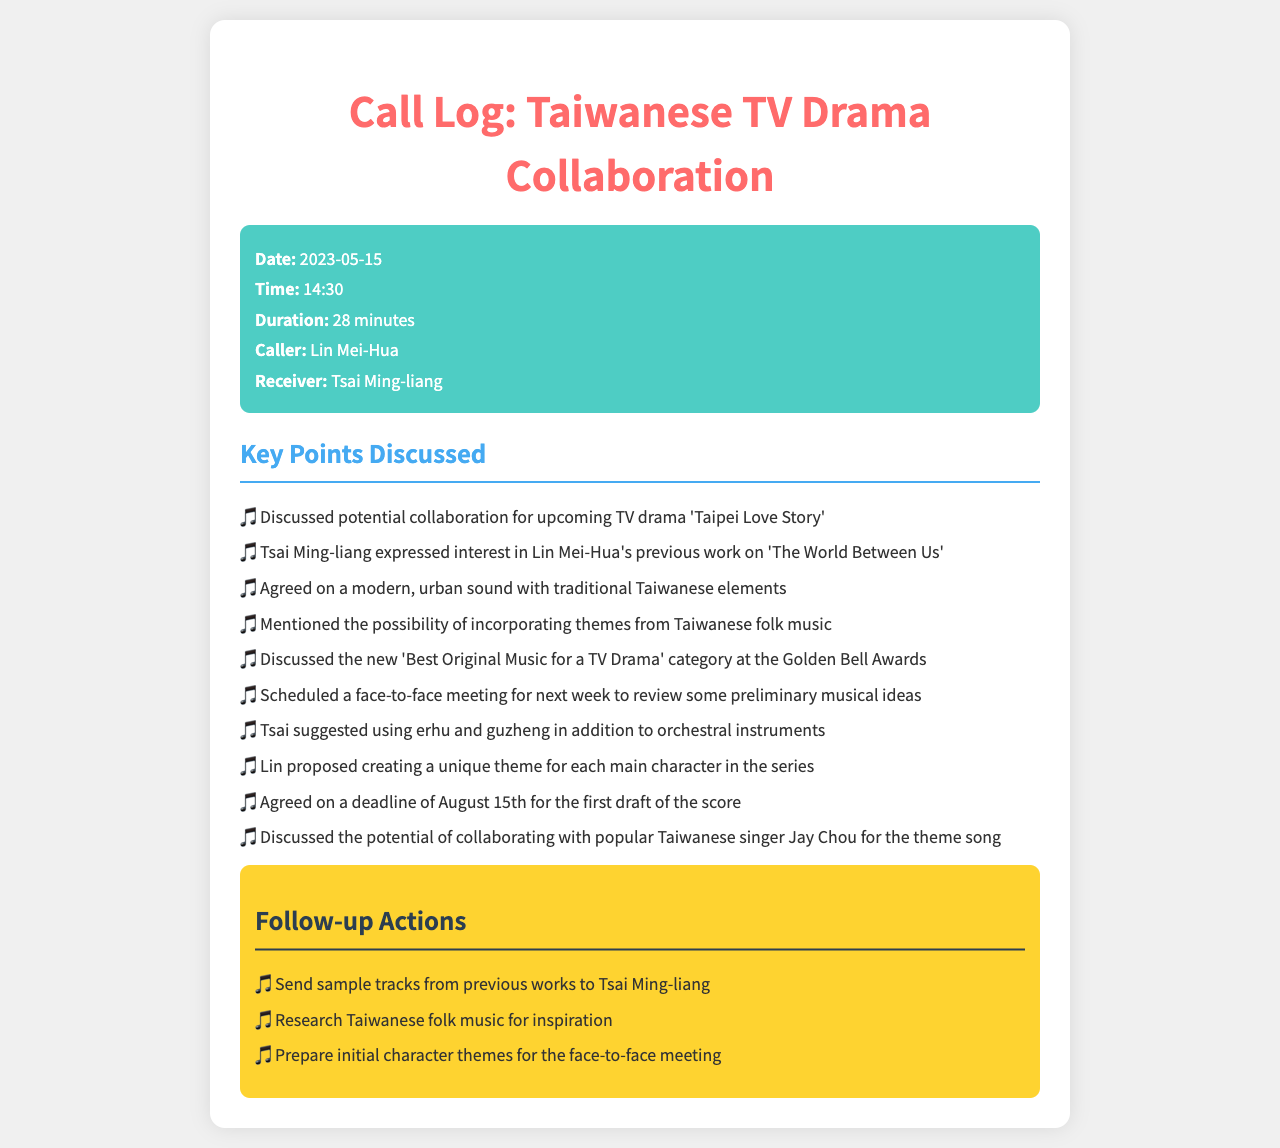What is the date of the call? The date of the call is stated in the call details section.
Answer: 2023-05-15 Who was the receiver of the call? The receiver of the call is mentioned as part of the call details.
Answer: Tsai Ming-liang What is the title of the upcoming TV drama discussed? The title is specifically mentioned in the key points discussed section.
Answer: Taipei Love Story What musical instruments did Tsai suggest using? This information is included in the list of key points discussed.
Answer: Erhu and guzheng What is the agreed deadline for the first draft of the score? The deadline is clearly stated in the key points discussed section.
Answer: August 15th What award category was discussed during the call? The specific award category is mentioned among the key points discussed.
Answer: Best Original Music for a TV Drama How long was the duration of the call? This information is provided in the call details section of the document.
Answer: 28 minutes What theme did Lin propose for the characters? This proposal is outlined in the key points discussed.
Answer: Unique theme for each main character What follow-up action involves sending tracks? This follow-up action is listed under follow-up actions.
Answer: Send sample tracks from previous works to Tsai Ming-liang 